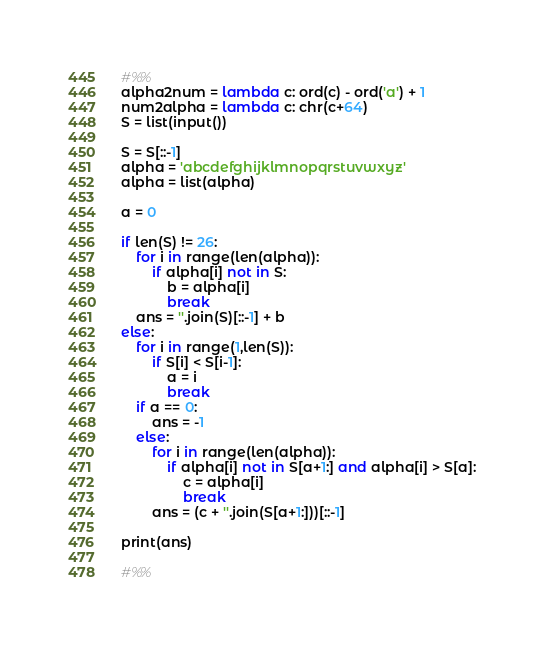<code> <loc_0><loc_0><loc_500><loc_500><_Python_>#%%
alpha2num = lambda c: ord(c) - ord('a') + 1
num2alpha = lambda c: chr(c+64)
S = list(input())

S = S[::-1]
alpha = 'abcdefghijklmnopqrstuvwxyz'
alpha = list(alpha)

a = 0

if len(S) != 26:
    for i in range(len(alpha)):
        if alpha[i] not in S:
            b = alpha[i]
            break
    ans = ''.join(S)[::-1] + b
else:
    for i in range(1,len(S)):
        if S[i] < S[i-1]:
            a = i
            break
    if a == 0:
        ans = -1
    else:
        for i in range(len(alpha)):
            if alpha[i] not in S[a+1:] and alpha[i] > S[a]:
                c = alpha[i]
                break
        ans = (c + ''.join(S[a+1:]))[::-1]

print(ans)

#%%
</code> 